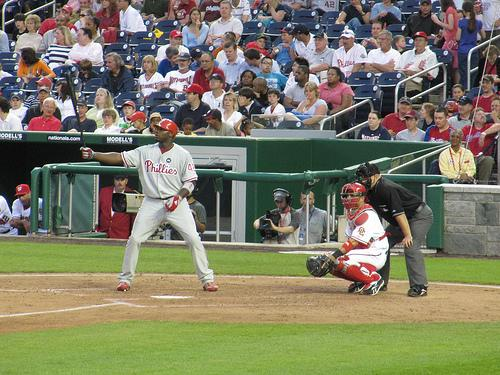List the objects and their colors that are present in the image. Men playing baseball, red helmet, white uniform, black glove, black mask, white lines, black shirt, right leg, lawn section, arm, shoe, black baseball bat, onlookers, camera, jersey, red shoes, red catcher's helmet, fans, headphones, catchers mitt. Who is wearing a black t-shirt in the image? A man, possibly the umpire, is wearing a black t-shirt in the image. Please provide a comprehensive description of the scene in this image. Men are playing baseball, one wearing a red helmet and white uniform, holding a black bat. The catcher has a black glove, and the umpire is behind him wearing a black mask and shirt. White lines are on the ground, and fans are watching the game in the baseball stadium. What type of headgear does the catcher wear? The catcher is wearing a red catcher's helmet. What piece of equipment is the baseball player holding in his hands? The baseball player is holding a black baseball bat in his hands. How many baseball shoes can be seen in the image and what color are they? Two red baseball shoes can be seen in the image. Please provide a brief description of the position of the player holding the bat and the catcher. The player holding the bat stands ready to swing, while the catcher squats down behind him with a black glove, ready to catch the ball. Is there any indication of the batter's team? Yes, the batter's team is the Phillies, as indicated by the logo on his shirt. What is the central activity taking place in this picture? The central activity taking place in the picture is men playing baseball. What color is the shirt of the umpire? The umpire's shirt is black. 